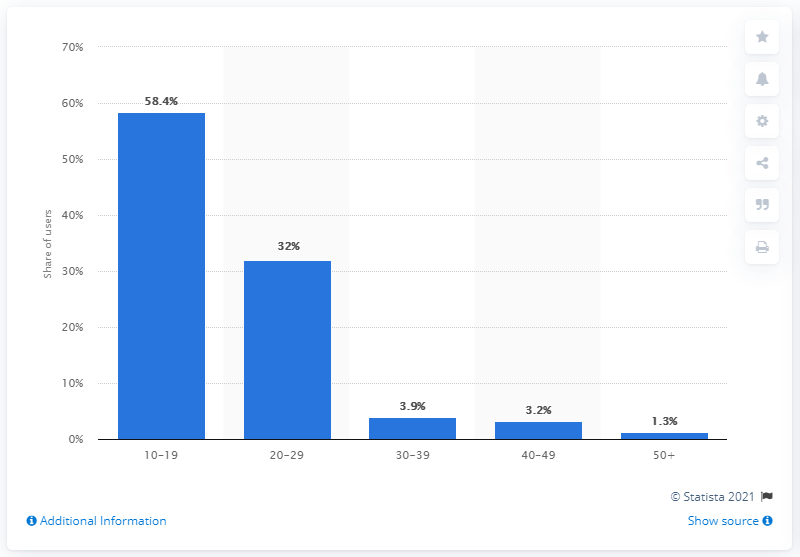Outline some significant characteristics in this image. In March of 2021, 58.4% of VSCO's active user accounts were teens. 